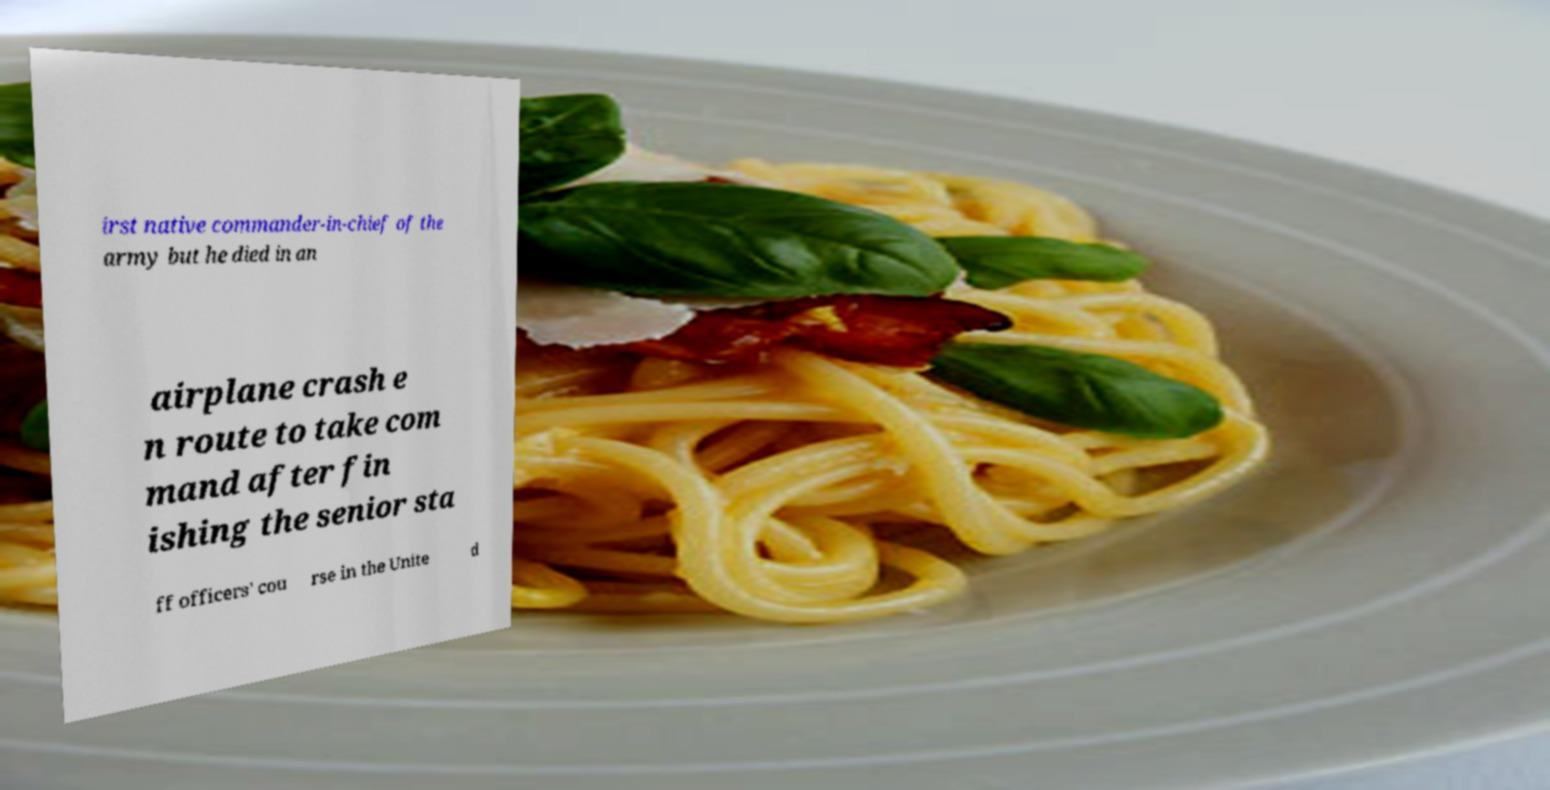Can you read and provide the text displayed in the image?This photo seems to have some interesting text. Can you extract and type it out for me? irst native commander-in-chief of the army but he died in an airplane crash e n route to take com mand after fin ishing the senior sta ff officers' cou rse in the Unite d 